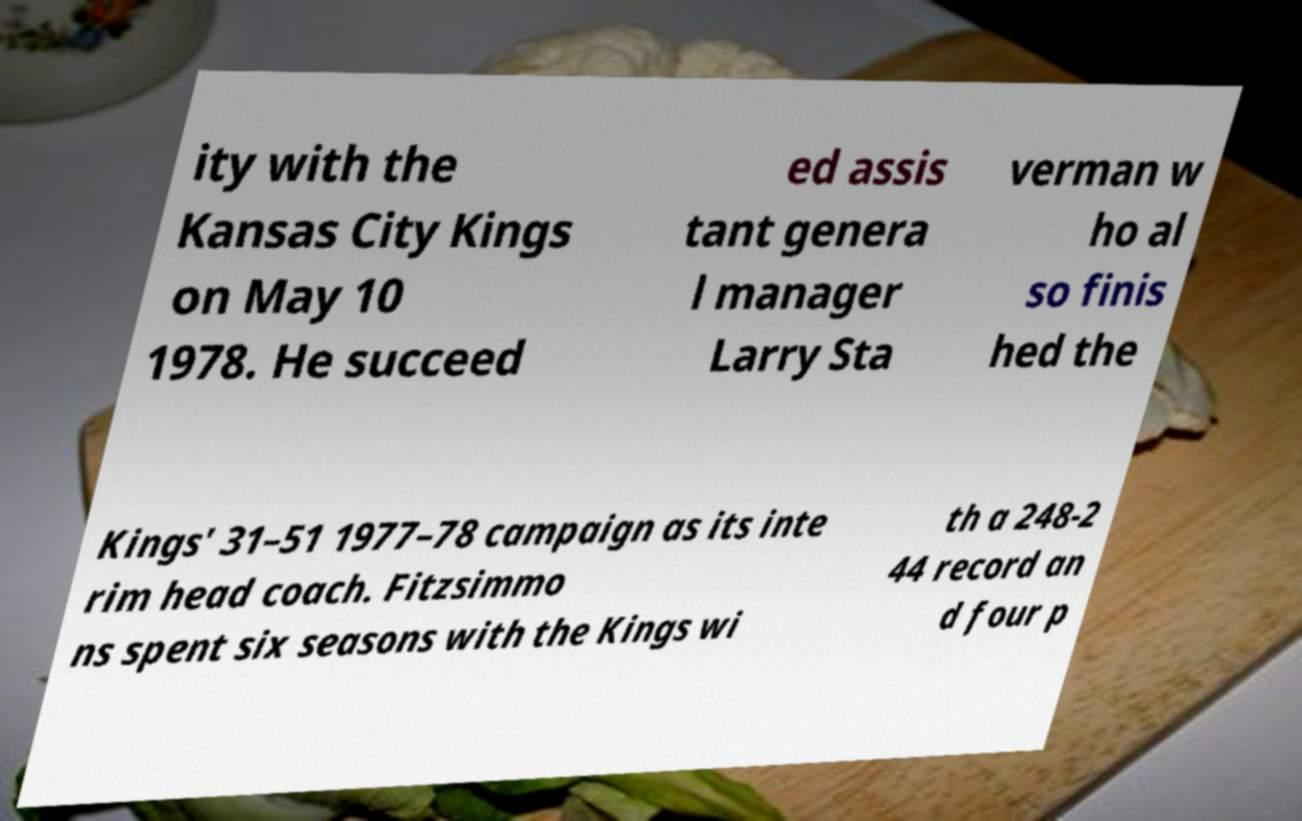What messages or text are displayed in this image? I need them in a readable, typed format. ity with the Kansas City Kings on May 10 1978. He succeed ed assis tant genera l manager Larry Sta verman w ho al so finis hed the Kings' 31–51 1977–78 campaign as its inte rim head coach. Fitzsimmo ns spent six seasons with the Kings wi th a 248-2 44 record an d four p 